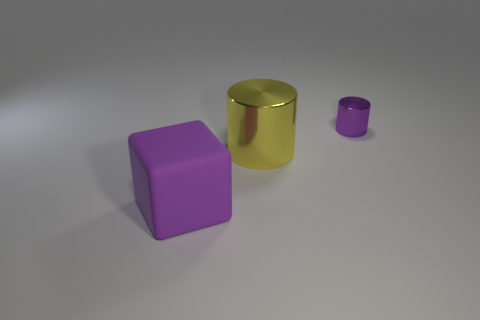Add 1 tiny green shiny cubes. How many objects exist? 4 Subtract all cubes. How many objects are left? 2 Subtract 0 green cubes. How many objects are left? 3 Subtract all purple cubes. Subtract all purple shiny cylinders. How many objects are left? 1 Add 3 small cylinders. How many small cylinders are left? 4 Add 1 small purple objects. How many small purple objects exist? 2 